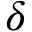Convert formula to latex. <formula><loc_0><loc_0><loc_500><loc_500>\delta</formula> 